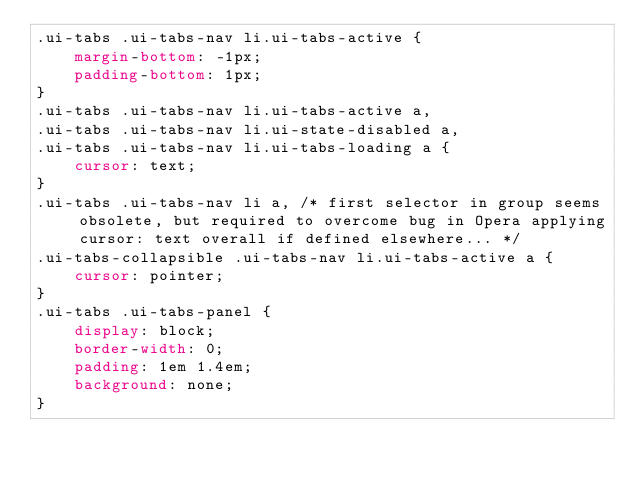Convert code to text. <code><loc_0><loc_0><loc_500><loc_500><_CSS_>.ui-tabs .ui-tabs-nav li.ui-tabs-active {
	margin-bottom: -1px;
	padding-bottom: 1px;
}
.ui-tabs .ui-tabs-nav li.ui-tabs-active a,
.ui-tabs .ui-tabs-nav li.ui-state-disabled a,
.ui-tabs .ui-tabs-nav li.ui-tabs-loading a {
	cursor: text;
}
.ui-tabs .ui-tabs-nav li a, /* first selector in group seems obsolete, but required to overcome bug in Opera applying cursor: text overall if defined elsewhere... */
.ui-tabs-collapsible .ui-tabs-nav li.ui-tabs-active a {
	cursor: pointer;
}
.ui-tabs .ui-tabs-panel {
	display: block;
	border-width: 0;
	padding: 1em 1.4em;
	background: none;
}
</code> 